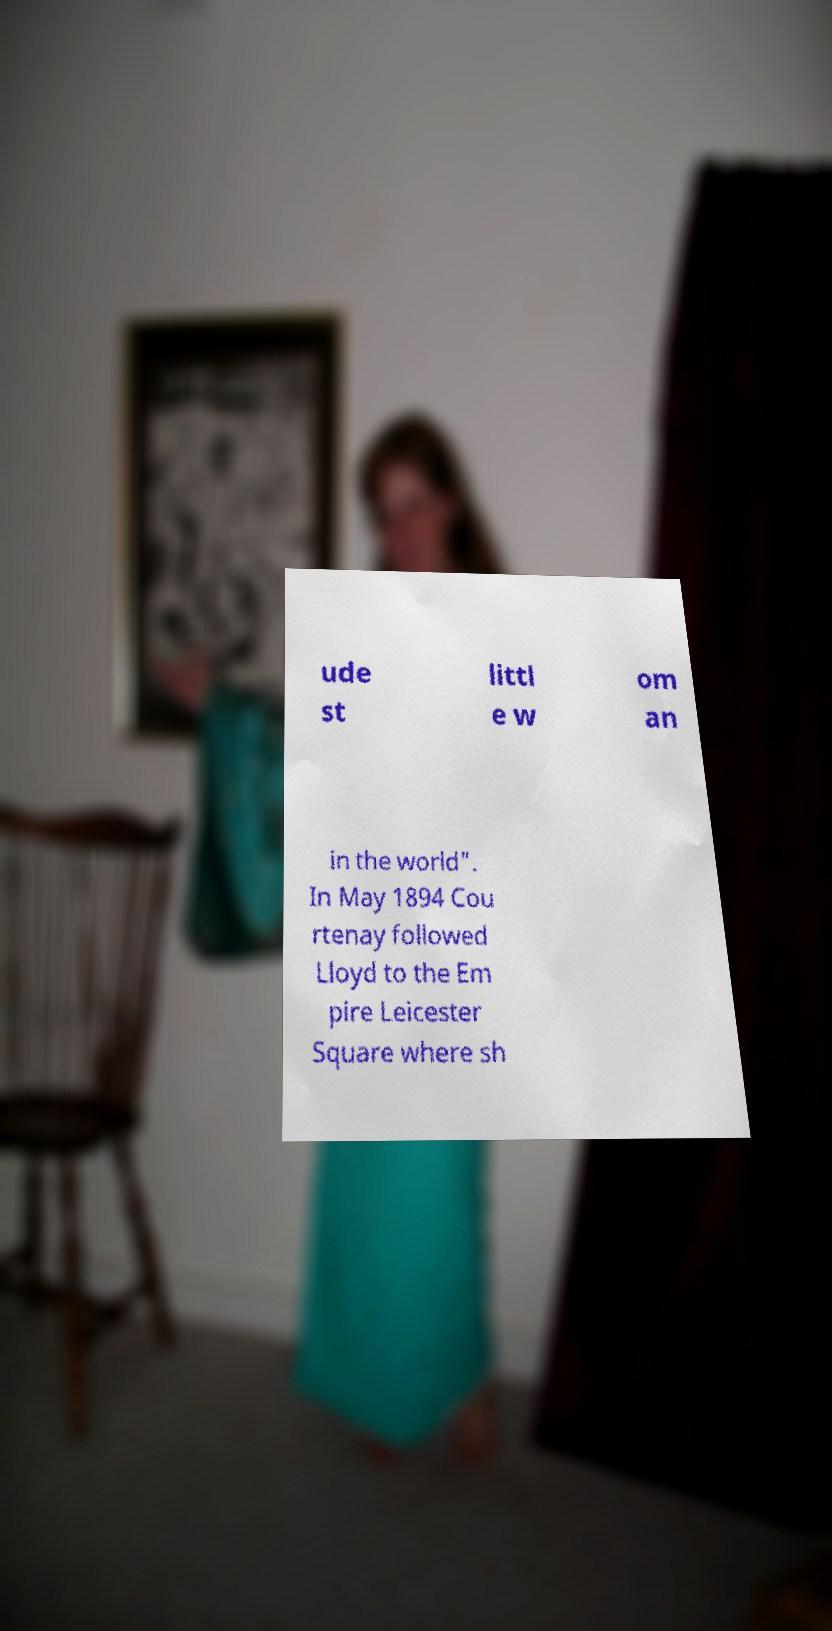I need the written content from this picture converted into text. Can you do that? ude st littl e w om an in the world". In May 1894 Cou rtenay followed Lloyd to the Em pire Leicester Square where sh 